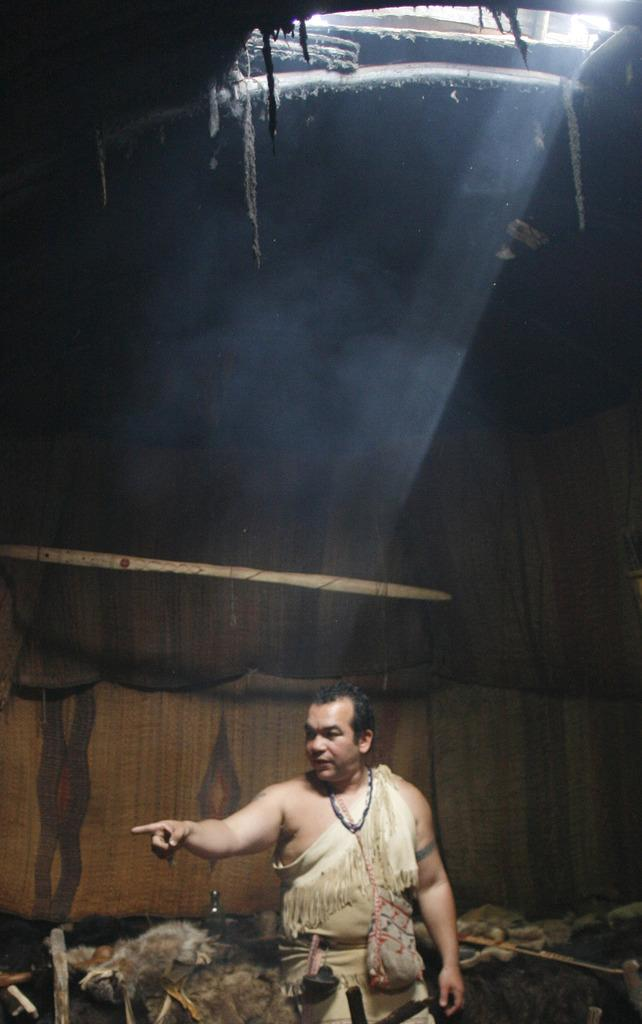What is the main subject of the image? There is a man standing in the image. Can you describe any other objects or structures in the image? There appears to be a tent in the image. How many lizards can be seen crawling on the man's hair in the image? There are no lizards present in the image, and the man's hair is not mentioned in the provided facts. 